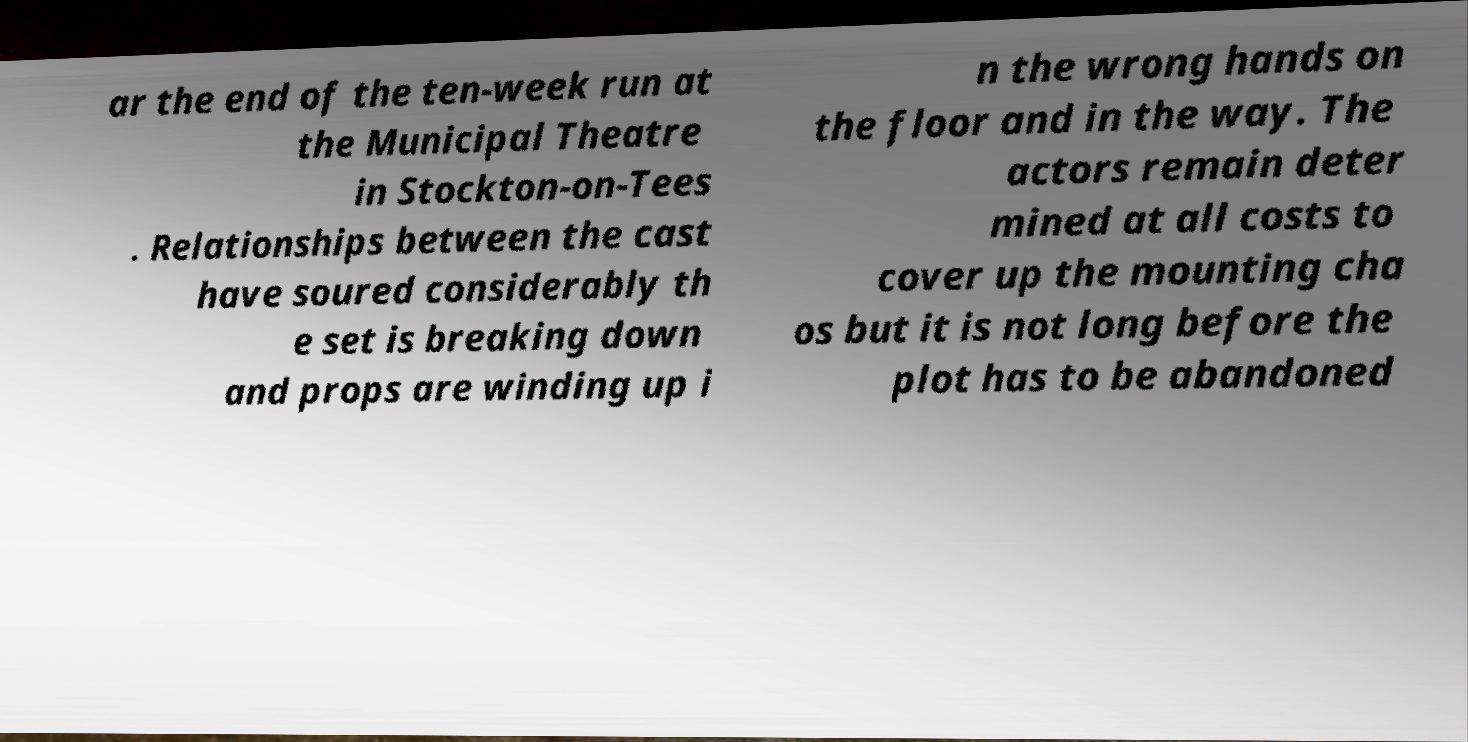Please read and relay the text visible in this image. What does it say? ar the end of the ten-week run at the Municipal Theatre in Stockton-on-Tees . Relationships between the cast have soured considerably th e set is breaking down and props are winding up i n the wrong hands on the floor and in the way. The actors remain deter mined at all costs to cover up the mounting cha os but it is not long before the plot has to be abandoned 